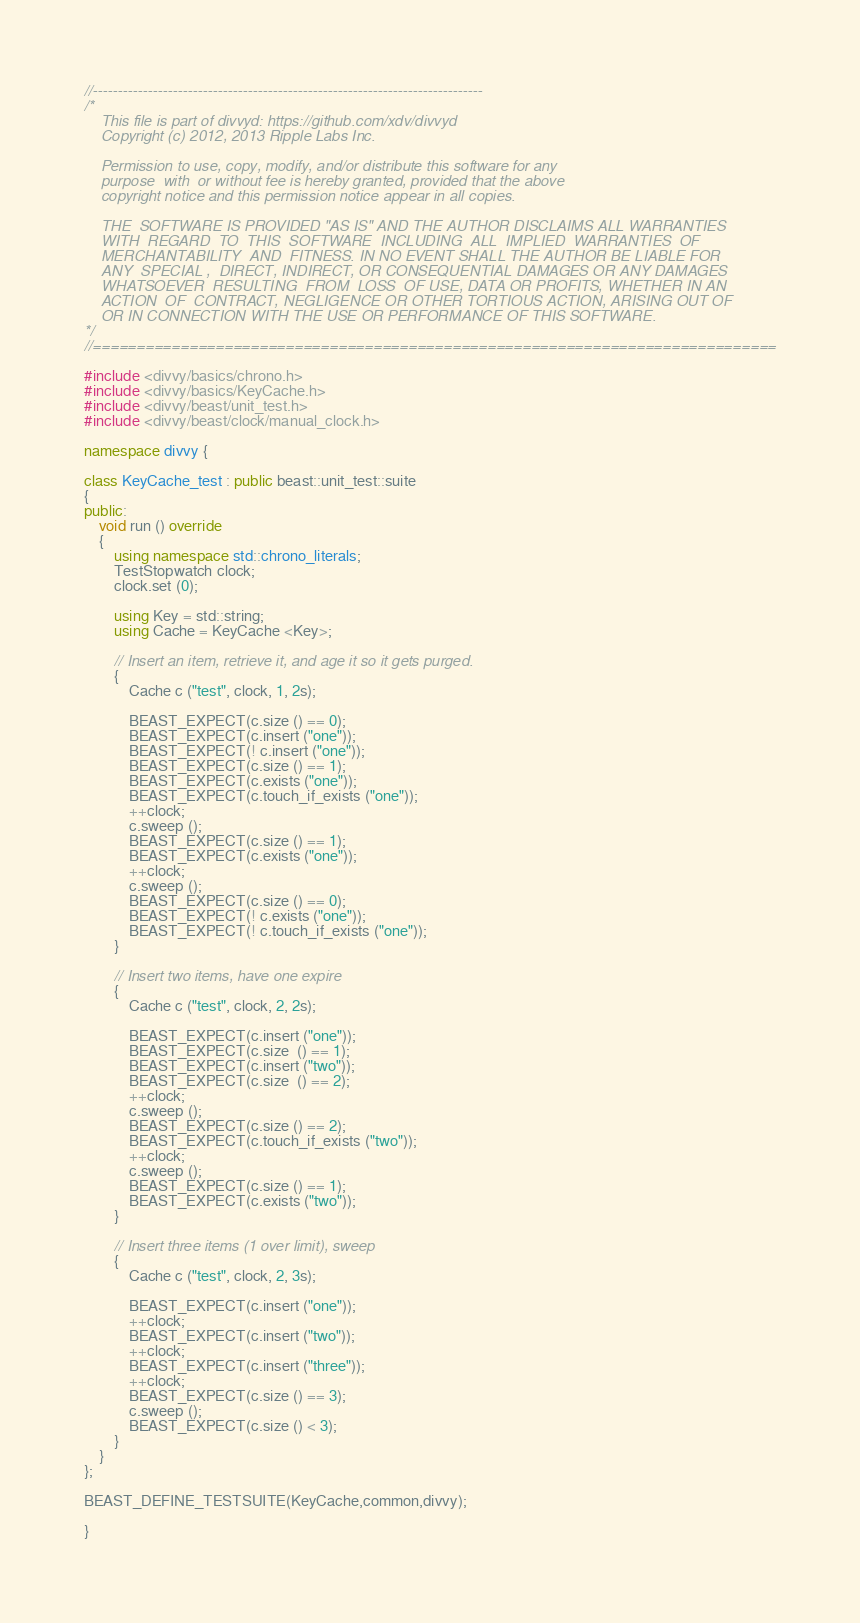<code> <loc_0><loc_0><loc_500><loc_500><_C++_>//------------------------------------------------------------------------------
/*
    This file is part of divvyd: https://github.com/xdv/divvyd
    Copyright (c) 2012, 2013 Ripple Labs Inc.

    Permission to use, copy, modify, and/or distribute this software for any
    purpose  with  or without fee is hereby granted, provided that the above
    copyright notice and this permission notice appear in all copies.

    THE  SOFTWARE IS PROVIDED "AS IS" AND THE AUTHOR DISCLAIMS ALL WARRANTIES
    WITH  REGARD  TO  THIS  SOFTWARE  INCLUDING  ALL  IMPLIED  WARRANTIES  OF
    MERCHANTABILITY  AND  FITNESS. IN NO EVENT SHALL THE AUTHOR BE LIABLE FOR
    ANY  SPECIAL ,  DIRECT, INDIRECT, OR CONSEQUENTIAL DAMAGES OR ANY DAMAGES
    WHATSOEVER  RESULTING  FROM  LOSS  OF USE, DATA OR PROFITS, WHETHER IN AN
    ACTION  OF  CONTRACT, NEGLIGENCE OR OTHER TORTIOUS ACTION, ARISING OUT OF
    OR IN CONNECTION WITH THE USE OR PERFORMANCE OF THIS SOFTWARE.
*/
//==============================================================================

#include <divvy/basics/chrono.h>
#include <divvy/basics/KeyCache.h>
#include <divvy/beast/unit_test.h>
#include <divvy/beast/clock/manual_clock.h>

namespace divvy {

class KeyCache_test : public beast::unit_test::suite
{
public:
    void run () override
    {
        using namespace std::chrono_literals;
        TestStopwatch clock;
        clock.set (0);

        using Key = std::string;
        using Cache = KeyCache <Key>;

        // Insert an item, retrieve it, and age it so it gets purged.
        {
            Cache c ("test", clock, 1, 2s);

            BEAST_EXPECT(c.size () == 0);
            BEAST_EXPECT(c.insert ("one"));
            BEAST_EXPECT(! c.insert ("one"));
            BEAST_EXPECT(c.size () == 1);
            BEAST_EXPECT(c.exists ("one"));
            BEAST_EXPECT(c.touch_if_exists ("one"));
            ++clock;
            c.sweep ();
            BEAST_EXPECT(c.size () == 1);
            BEAST_EXPECT(c.exists ("one"));
            ++clock;
            c.sweep ();
            BEAST_EXPECT(c.size () == 0);
            BEAST_EXPECT(! c.exists ("one"));
            BEAST_EXPECT(! c.touch_if_exists ("one"));
        }

        // Insert two items, have one expire
        {
            Cache c ("test", clock, 2, 2s);

            BEAST_EXPECT(c.insert ("one"));
            BEAST_EXPECT(c.size  () == 1);
            BEAST_EXPECT(c.insert ("two"));
            BEAST_EXPECT(c.size  () == 2);
            ++clock;
            c.sweep ();
            BEAST_EXPECT(c.size () == 2);
            BEAST_EXPECT(c.touch_if_exists ("two"));
            ++clock;
            c.sweep ();
            BEAST_EXPECT(c.size () == 1);
            BEAST_EXPECT(c.exists ("two"));
        }

        // Insert three items (1 over limit), sweep
        {
            Cache c ("test", clock, 2, 3s);

            BEAST_EXPECT(c.insert ("one"));
            ++clock;
            BEAST_EXPECT(c.insert ("two"));
            ++clock;
            BEAST_EXPECT(c.insert ("three"));
            ++clock;
            BEAST_EXPECT(c.size () == 3);
            c.sweep ();
            BEAST_EXPECT(c.size () < 3);
        }
    }
};

BEAST_DEFINE_TESTSUITE(KeyCache,common,divvy);

}
</code> 